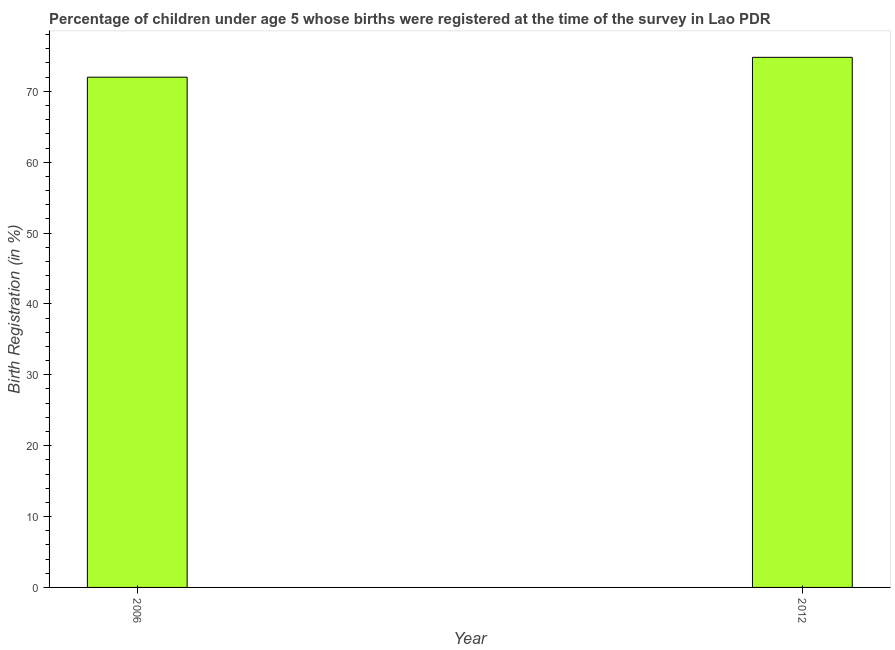What is the title of the graph?
Your response must be concise. Percentage of children under age 5 whose births were registered at the time of the survey in Lao PDR. What is the label or title of the X-axis?
Make the answer very short. Year. What is the label or title of the Y-axis?
Your response must be concise. Birth Registration (in %). What is the birth registration in 2006?
Provide a succinct answer. 72. Across all years, what is the maximum birth registration?
Offer a very short reply. 74.8. Across all years, what is the minimum birth registration?
Your answer should be compact. 72. In which year was the birth registration maximum?
Offer a terse response. 2012. In which year was the birth registration minimum?
Your answer should be compact. 2006. What is the sum of the birth registration?
Your answer should be compact. 146.8. What is the difference between the birth registration in 2006 and 2012?
Provide a short and direct response. -2.8. What is the average birth registration per year?
Your response must be concise. 73.4. What is the median birth registration?
Offer a very short reply. 73.4. In how many years, is the birth registration greater than 2 %?
Keep it short and to the point. 2. Do a majority of the years between 2006 and 2012 (inclusive) have birth registration greater than 22 %?
Keep it short and to the point. Yes. In how many years, is the birth registration greater than the average birth registration taken over all years?
Make the answer very short. 1. Are all the bars in the graph horizontal?
Provide a short and direct response. No. How many years are there in the graph?
Make the answer very short. 2. Are the values on the major ticks of Y-axis written in scientific E-notation?
Offer a very short reply. No. What is the Birth Registration (in %) of 2006?
Provide a short and direct response. 72. What is the Birth Registration (in %) in 2012?
Give a very brief answer. 74.8. What is the ratio of the Birth Registration (in %) in 2006 to that in 2012?
Your response must be concise. 0.96. 